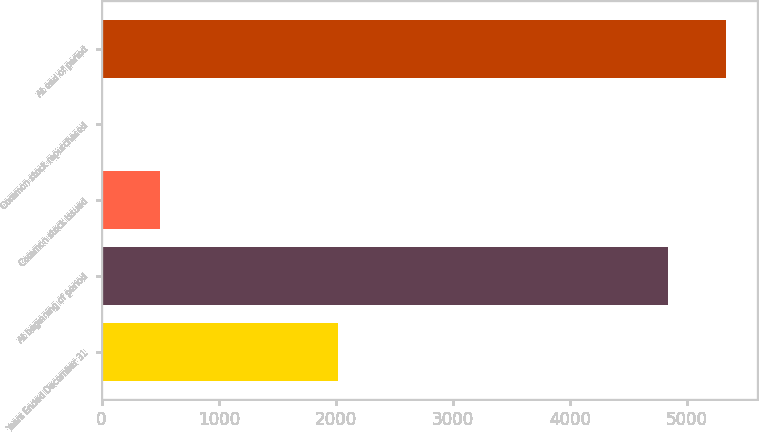Convert chart. <chart><loc_0><loc_0><loc_500><loc_500><bar_chart><fcel>Years Ended December 31<fcel>At beginning of period<fcel>Common stock issued<fcel>Common stock repurchased<fcel>At end of period<nl><fcel>2016<fcel>4837<fcel>501.5<fcel>11<fcel>5327.5<nl></chart> 